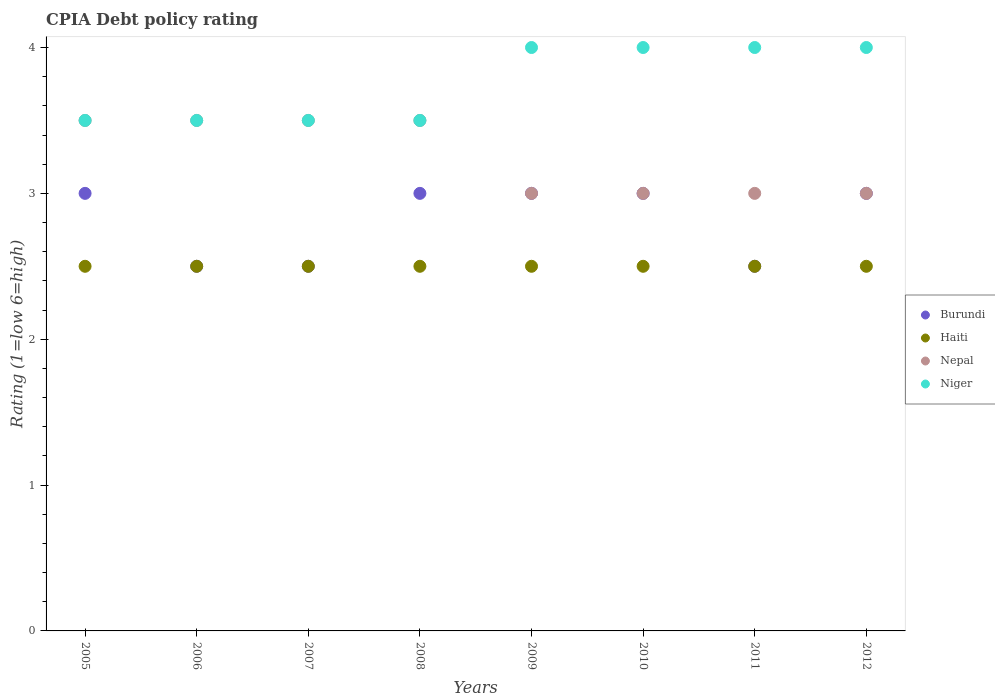Across all years, what is the maximum CPIA rating in Haiti?
Ensure brevity in your answer.  2.5. Across all years, what is the minimum CPIA rating in Niger?
Provide a succinct answer. 3.5. In which year was the CPIA rating in Haiti maximum?
Provide a succinct answer. 2005. What is the total CPIA rating in Niger in the graph?
Keep it short and to the point. 30. What is the difference between the CPIA rating in Haiti in 2008 and that in 2012?
Give a very brief answer. 0. What is the average CPIA rating in Niger per year?
Provide a short and direct response. 3.75. In the year 2012, what is the difference between the CPIA rating in Niger and CPIA rating in Nepal?
Offer a very short reply. 1. In how many years, is the CPIA rating in Nepal greater than 0.4?
Ensure brevity in your answer.  8. What is the difference between the highest and the lowest CPIA rating in Nepal?
Offer a very short reply. 0.5. In how many years, is the CPIA rating in Burundi greater than the average CPIA rating in Burundi taken over all years?
Make the answer very short. 5. Is the sum of the CPIA rating in Burundi in 2007 and 2011 greater than the maximum CPIA rating in Haiti across all years?
Offer a terse response. Yes. Is it the case that in every year, the sum of the CPIA rating in Haiti and CPIA rating in Nepal  is greater than the sum of CPIA rating in Niger and CPIA rating in Burundi?
Your answer should be compact. No. Is the CPIA rating in Niger strictly greater than the CPIA rating in Nepal over the years?
Your answer should be very brief. No. Is the CPIA rating in Haiti strictly less than the CPIA rating in Burundi over the years?
Your answer should be compact. No. How many dotlines are there?
Provide a short and direct response. 4. How many years are there in the graph?
Offer a very short reply. 8. Are the values on the major ticks of Y-axis written in scientific E-notation?
Provide a short and direct response. No. Does the graph contain grids?
Provide a short and direct response. No. Where does the legend appear in the graph?
Ensure brevity in your answer.  Center right. How many legend labels are there?
Offer a very short reply. 4. What is the title of the graph?
Ensure brevity in your answer.  CPIA Debt policy rating. What is the label or title of the Y-axis?
Offer a terse response. Rating (1=low 6=high). What is the Rating (1=low 6=high) of Burundi in 2005?
Offer a terse response. 3. What is the Rating (1=low 6=high) in Haiti in 2005?
Give a very brief answer. 2.5. What is the Rating (1=low 6=high) in Nepal in 2005?
Provide a short and direct response. 3.5. What is the Rating (1=low 6=high) in Niger in 2005?
Your answer should be compact. 3.5. What is the Rating (1=low 6=high) in Haiti in 2006?
Offer a terse response. 2.5. What is the Rating (1=low 6=high) of Niger in 2006?
Offer a terse response. 3.5. What is the Rating (1=low 6=high) of Burundi in 2007?
Your answer should be very brief. 2.5. What is the Rating (1=low 6=high) of Haiti in 2008?
Provide a short and direct response. 2.5. What is the Rating (1=low 6=high) in Nepal in 2008?
Give a very brief answer. 3.5. What is the Rating (1=low 6=high) in Burundi in 2009?
Make the answer very short. 3. What is the Rating (1=low 6=high) of Haiti in 2009?
Provide a short and direct response. 2.5. What is the Rating (1=low 6=high) of Haiti in 2010?
Provide a short and direct response. 2.5. What is the Rating (1=low 6=high) in Nepal in 2010?
Your answer should be compact. 3. What is the Rating (1=low 6=high) in Niger in 2010?
Your answer should be very brief. 4. What is the Rating (1=low 6=high) in Burundi in 2011?
Give a very brief answer. 2.5. What is the Rating (1=low 6=high) in Haiti in 2011?
Give a very brief answer. 2.5. What is the Rating (1=low 6=high) of Burundi in 2012?
Make the answer very short. 3. What is the Rating (1=low 6=high) in Haiti in 2012?
Offer a terse response. 2.5. What is the Rating (1=low 6=high) of Nepal in 2012?
Your answer should be compact. 3. Across all years, what is the maximum Rating (1=low 6=high) of Burundi?
Offer a terse response. 3. Across all years, what is the maximum Rating (1=low 6=high) in Nepal?
Ensure brevity in your answer.  3.5. Across all years, what is the minimum Rating (1=low 6=high) in Burundi?
Your answer should be very brief. 2.5. Across all years, what is the minimum Rating (1=low 6=high) of Nepal?
Make the answer very short. 3. What is the difference between the Rating (1=low 6=high) of Burundi in 2005 and that in 2006?
Ensure brevity in your answer.  0.5. What is the difference between the Rating (1=low 6=high) in Niger in 2005 and that in 2006?
Ensure brevity in your answer.  0. What is the difference between the Rating (1=low 6=high) of Nepal in 2005 and that in 2007?
Offer a terse response. 0. What is the difference between the Rating (1=low 6=high) in Niger in 2005 and that in 2007?
Keep it short and to the point. 0. What is the difference between the Rating (1=low 6=high) in Nepal in 2005 and that in 2008?
Keep it short and to the point. 0. What is the difference between the Rating (1=low 6=high) of Niger in 2005 and that in 2008?
Your answer should be very brief. 0. What is the difference between the Rating (1=low 6=high) of Nepal in 2005 and that in 2009?
Provide a succinct answer. 0.5. What is the difference between the Rating (1=low 6=high) in Burundi in 2005 and that in 2011?
Give a very brief answer. 0.5. What is the difference between the Rating (1=low 6=high) in Haiti in 2005 and that in 2011?
Keep it short and to the point. 0. What is the difference between the Rating (1=low 6=high) of Niger in 2005 and that in 2011?
Your answer should be very brief. -0.5. What is the difference between the Rating (1=low 6=high) of Burundi in 2005 and that in 2012?
Offer a very short reply. 0. What is the difference between the Rating (1=low 6=high) of Nepal in 2005 and that in 2012?
Offer a very short reply. 0.5. What is the difference between the Rating (1=low 6=high) in Burundi in 2006 and that in 2007?
Provide a succinct answer. 0. What is the difference between the Rating (1=low 6=high) of Burundi in 2006 and that in 2008?
Keep it short and to the point. -0.5. What is the difference between the Rating (1=low 6=high) in Haiti in 2006 and that in 2008?
Ensure brevity in your answer.  0. What is the difference between the Rating (1=low 6=high) of Nepal in 2006 and that in 2008?
Give a very brief answer. 0. What is the difference between the Rating (1=low 6=high) in Niger in 2006 and that in 2008?
Provide a succinct answer. 0. What is the difference between the Rating (1=low 6=high) of Niger in 2006 and that in 2009?
Make the answer very short. -0.5. What is the difference between the Rating (1=low 6=high) in Burundi in 2006 and that in 2010?
Offer a very short reply. -0.5. What is the difference between the Rating (1=low 6=high) of Niger in 2006 and that in 2010?
Provide a short and direct response. -0.5. What is the difference between the Rating (1=low 6=high) in Nepal in 2006 and that in 2011?
Your answer should be compact. 0.5. What is the difference between the Rating (1=low 6=high) of Burundi in 2006 and that in 2012?
Offer a very short reply. -0.5. What is the difference between the Rating (1=low 6=high) in Haiti in 2006 and that in 2012?
Your answer should be very brief. 0. What is the difference between the Rating (1=low 6=high) of Haiti in 2007 and that in 2008?
Your response must be concise. 0. What is the difference between the Rating (1=low 6=high) in Haiti in 2007 and that in 2009?
Your answer should be compact. 0. What is the difference between the Rating (1=low 6=high) in Burundi in 2007 and that in 2010?
Keep it short and to the point. -0.5. What is the difference between the Rating (1=low 6=high) in Haiti in 2007 and that in 2010?
Provide a short and direct response. 0. What is the difference between the Rating (1=low 6=high) in Haiti in 2007 and that in 2011?
Provide a succinct answer. 0. What is the difference between the Rating (1=low 6=high) of Burundi in 2007 and that in 2012?
Provide a short and direct response. -0.5. What is the difference between the Rating (1=low 6=high) in Haiti in 2007 and that in 2012?
Make the answer very short. 0. What is the difference between the Rating (1=low 6=high) in Burundi in 2008 and that in 2009?
Your response must be concise. 0. What is the difference between the Rating (1=low 6=high) in Haiti in 2008 and that in 2009?
Make the answer very short. 0. What is the difference between the Rating (1=low 6=high) in Niger in 2008 and that in 2009?
Your response must be concise. -0.5. What is the difference between the Rating (1=low 6=high) in Nepal in 2008 and that in 2010?
Your answer should be very brief. 0.5. What is the difference between the Rating (1=low 6=high) in Niger in 2008 and that in 2010?
Your response must be concise. -0.5. What is the difference between the Rating (1=low 6=high) of Burundi in 2008 and that in 2011?
Offer a very short reply. 0.5. What is the difference between the Rating (1=low 6=high) in Haiti in 2008 and that in 2011?
Your answer should be very brief. 0. What is the difference between the Rating (1=low 6=high) in Burundi in 2008 and that in 2012?
Provide a short and direct response. 0. What is the difference between the Rating (1=low 6=high) of Haiti in 2008 and that in 2012?
Offer a terse response. 0. What is the difference between the Rating (1=low 6=high) of Nepal in 2008 and that in 2012?
Offer a terse response. 0.5. What is the difference between the Rating (1=low 6=high) of Haiti in 2009 and that in 2010?
Make the answer very short. 0. What is the difference between the Rating (1=low 6=high) in Haiti in 2009 and that in 2011?
Provide a short and direct response. 0. What is the difference between the Rating (1=low 6=high) in Nepal in 2009 and that in 2011?
Your response must be concise. 0. What is the difference between the Rating (1=low 6=high) of Niger in 2009 and that in 2011?
Ensure brevity in your answer.  0. What is the difference between the Rating (1=low 6=high) in Burundi in 2009 and that in 2012?
Your response must be concise. 0. What is the difference between the Rating (1=low 6=high) of Haiti in 2009 and that in 2012?
Your answer should be compact. 0. What is the difference between the Rating (1=low 6=high) of Nepal in 2009 and that in 2012?
Keep it short and to the point. 0. What is the difference between the Rating (1=low 6=high) of Burundi in 2010 and that in 2011?
Give a very brief answer. 0.5. What is the difference between the Rating (1=low 6=high) of Haiti in 2010 and that in 2011?
Provide a succinct answer. 0. What is the difference between the Rating (1=low 6=high) of Nepal in 2010 and that in 2011?
Give a very brief answer. 0. What is the difference between the Rating (1=low 6=high) of Niger in 2010 and that in 2011?
Your response must be concise. 0. What is the difference between the Rating (1=low 6=high) of Haiti in 2011 and that in 2012?
Your response must be concise. 0. What is the difference between the Rating (1=low 6=high) of Niger in 2011 and that in 2012?
Offer a very short reply. 0. What is the difference between the Rating (1=low 6=high) in Burundi in 2005 and the Rating (1=low 6=high) in Haiti in 2006?
Keep it short and to the point. 0.5. What is the difference between the Rating (1=low 6=high) of Burundi in 2005 and the Rating (1=low 6=high) of Nepal in 2006?
Your answer should be compact. -0.5. What is the difference between the Rating (1=low 6=high) of Burundi in 2005 and the Rating (1=low 6=high) of Niger in 2006?
Make the answer very short. -0.5. What is the difference between the Rating (1=low 6=high) in Nepal in 2005 and the Rating (1=low 6=high) in Niger in 2006?
Offer a terse response. 0. What is the difference between the Rating (1=low 6=high) of Burundi in 2005 and the Rating (1=low 6=high) of Haiti in 2007?
Keep it short and to the point. 0.5. What is the difference between the Rating (1=low 6=high) in Burundi in 2005 and the Rating (1=low 6=high) in Nepal in 2007?
Make the answer very short. -0.5. What is the difference between the Rating (1=low 6=high) in Haiti in 2005 and the Rating (1=low 6=high) in Niger in 2007?
Offer a very short reply. -1. What is the difference between the Rating (1=low 6=high) in Burundi in 2005 and the Rating (1=low 6=high) in Haiti in 2008?
Provide a short and direct response. 0.5. What is the difference between the Rating (1=low 6=high) in Burundi in 2005 and the Rating (1=low 6=high) in Nepal in 2008?
Give a very brief answer. -0.5. What is the difference between the Rating (1=low 6=high) of Haiti in 2005 and the Rating (1=low 6=high) of Niger in 2008?
Keep it short and to the point. -1. What is the difference between the Rating (1=low 6=high) in Nepal in 2005 and the Rating (1=low 6=high) in Niger in 2008?
Make the answer very short. 0. What is the difference between the Rating (1=low 6=high) in Burundi in 2005 and the Rating (1=low 6=high) in Nepal in 2009?
Your response must be concise. 0. What is the difference between the Rating (1=low 6=high) of Burundi in 2005 and the Rating (1=low 6=high) of Niger in 2009?
Your response must be concise. -1. What is the difference between the Rating (1=low 6=high) in Nepal in 2005 and the Rating (1=low 6=high) in Niger in 2009?
Ensure brevity in your answer.  -0.5. What is the difference between the Rating (1=low 6=high) of Burundi in 2005 and the Rating (1=low 6=high) of Haiti in 2010?
Make the answer very short. 0.5. What is the difference between the Rating (1=low 6=high) of Burundi in 2005 and the Rating (1=low 6=high) of Nepal in 2010?
Provide a succinct answer. 0. What is the difference between the Rating (1=low 6=high) of Burundi in 2005 and the Rating (1=low 6=high) of Niger in 2010?
Keep it short and to the point. -1. What is the difference between the Rating (1=low 6=high) in Haiti in 2005 and the Rating (1=low 6=high) in Niger in 2010?
Make the answer very short. -1.5. What is the difference between the Rating (1=low 6=high) of Burundi in 2005 and the Rating (1=low 6=high) of Nepal in 2011?
Keep it short and to the point. 0. What is the difference between the Rating (1=low 6=high) in Haiti in 2005 and the Rating (1=low 6=high) in Niger in 2011?
Give a very brief answer. -1.5. What is the difference between the Rating (1=low 6=high) in Burundi in 2005 and the Rating (1=low 6=high) in Niger in 2012?
Ensure brevity in your answer.  -1. What is the difference between the Rating (1=low 6=high) of Haiti in 2005 and the Rating (1=low 6=high) of Nepal in 2012?
Provide a succinct answer. -0.5. What is the difference between the Rating (1=low 6=high) in Haiti in 2005 and the Rating (1=low 6=high) in Niger in 2012?
Offer a terse response. -1.5. What is the difference between the Rating (1=low 6=high) in Nepal in 2005 and the Rating (1=low 6=high) in Niger in 2012?
Offer a terse response. -0.5. What is the difference between the Rating (1=low 6=high) in Burundi in 2006 and the Rating (1=low 6=high) in Haiti in 2007?
Keep it short and to the point. 0. What is the difference between the Rating (1=low 6=high) in Burundi in 2006 and the Rating (1=low 6=high) in Nepal in 2007?
Ensure brevity in your answer.  -1. What is the difference between the Rating (1=low 6=high) in Haiti in 2006 and the Rating (1=low 6=high) in Niger in 2007?
Provide a succinct answer. -1. What is the difference between the Rating (1=low 6=high) in Burundi in 2006 and the Rating (1=low 6=high) in Nepal in 2008?
Ensure brevity in your answer.  -1. What is the difference between the Rating (1=low 6=high) in Burundi in 2006 and the Rating (1=low 6=high) in Niger in 2009?
Keep it short and to the point. -1.5. What is the difference between the Rating (1=low 6=high) of Haiti in 2006 and the Rating (1=low 6=high) of Nepal in 2009?
Provide a succinct answer. -0.5. What is the difference between the Rating (1=low 6=high) of Nepal in 2006 and the Rating (1=low 6=high) of Niger in 2009?
Keep it short and to the point. -0.5. What is the difference between the Rating (1=low 6=high) of Burundi in 2006 and the Rating (1=low 6=high) of Haiti in 2010?
Make the answer very short. 0. What is the difference between the Rating (1=low 6=high) of Burundi in 2006 and the Rating (1=low 6=high) of Nepal in 2010?
Offer a very short reply. -0.5. What is the difference between the Rating (1=low 6=high) of Burundi in 2006 and the Rating (1=low 6=high) of Niger in 2010?
Provide a short and direct response. -1.5. What is the difference between the Rating (1=low 6=high) in Haiti in 2006 and the Rating (1=low 6=high) in Nepal in 2010?
Make the answer very short. -0.5. What is the difference between the Rating (1=low 6=high) of Haiti in 2006 and the Rating (1=low 6=high) of Niger in 2010?
Offer a very short reply. -1.5. What is the difference between the Rating (1=low 6=high) in Burundi in 2006 and the Rating (1=low 6=high) in Haiti in 2011?
Offer a terse response. 0. What is the difference between the Rating (1=low 6=high) of Burundi in 2006 and the Rating (1=low 6=high) of Nepal in 2011?
Make the answer very short. -0.5. What is the difference between the Rating (1=low 6=high) of Burundi in 2006 and the Rating (1=low 6=high) of Niger in 2011?
Your answer should be very brief. -1.5. What is the difference between the Rating (1=low 6=high) in Haiti in 2006 and the Rating (1=low 6=high) in Nepal in 2011?
Offer a terse response. -0.5. What is the difference between the Rating (1=low 6=high) of Haiti in 2006 and the Rating (1=low 6=high) of Niger in 2011?
Offer a very short reply. -1.5. What is the difference between the Rating (1=low 6=high) of Nepal in 2006 and the Rating (1=low 6=high) of Niger in 2011?
Ensure brevity in your answer.  -0.5. What is the difference between the Rating (1=low 6=high) of Burundi in 2006 and the Rating (1=low 6=high) of Haiti in 2012?
Offer a terse response. 0. What is the difference between the Rating (1=low 6=high) of Burundi in 2006 and the Rating (1=low 6=high) of Nepal in 2012?
Keep it short and to the point. -0.5. What is the difference between the Rating (1=low 6=high) in Haiti in 2006 and the Rating (1=low 6=high) in Niger in 2012?
Provide a succinct answer. -1.5. What is the difference between the Rating (1=low 6=high) of Nepal in 2006 and the Rating (1=low 6=high) of Niger in 2012?
Your response must be concise. -0.5. What is the difference between the Rating (1=low 6=high) of Haiti in 2007 and the Rating (1=low 6=high) of Nepal in 2008?
Offer a terse response. -1. What is the difference between the Rating (1=low 6=high) in Nepal in 2007 and the Rating (1=low 6=high) in Niger in 2008?
Give a very brief answer. 0. What is the difference between the Rating (1=low 6=high) of Burundi in 2007 and the Rating (1=low 6=high) of Nepal in 2009?
Your answer should be very brief. -0.5. What is the difference between the Rating (1=low 6=high) in Haiti in 2007 and the Rating (1=low 6=high) in Nepal in 2009?
Ensure brevity in your answer.  -0.5. What is the difference between the Rating (1=low 6=high) in Haiti in 2007 and the Rating (1=low 6=high) in Niger in 2009?
Provide a succinct answer. -1.5. What is the difference between the Rating (1=low 6=high) of Haiti in 2007 and the Rating (1=low 6=high) of Niger in 2010?
Offer a very short reply. -1.5. What is the difference between the Rating (1=low 6=high) in Burundi in 2007 and the Rating (1=low 6=high) in Haiti in 2011?
Your answer should be compact. 0. What is the difference between the Rating (1=low 6=high) in Nepal in 2007 and the Rating (1=low 6=high) in Niger in 2011?
Your answer should be very brief. -0.5. What is the difference between the Rating (1=low 6=high) of Burundi in 2007 and the Rating (1=low 6=high) of Haiti in 2012?
Ensure brevity in your answer.  0. What is the difference between the Rating (1=low 6=high) of Haiti in 2007 and the Rating (1=low 6=high) of Nepal in 2012?
Offer a very short reply. -0.5. What is the difference between the Rating (1=low 6=high) of Nepal in 2007 and the Rating (1=low 6=high) of Niger in 2012?
Offer a very short reply. -0.5. What is the difference between the Rating (1=low 6=high) in Burundi in 2008 and the Rating (1=low 6=high) in Niger in 2009?
Ensure brevity in your answer.  -1. What is the difference between the Rating (1=low 6=high) in Burundi in 2008 and the Rating (1=low 6=high) in Nepal in 2010?
Keep it short and to the point. 0. What is the difference between the Rating (1=low 6=high) in Haiti in 2008 and the Rating (1=low 6=high) in Niger in 2010?
Provide a succinct answer. -1.5. What is the difference between the Rating (1=low 6=high) of Nepal in 2008 and the Rating (1=low 6=high) of Niger in 2010?
Your answer should be very brief. -0.5. What is the difference between the Rating (1=low 6=high) in Burundi in 2008 and the Rating (1=low 6=high) in Nepal in 2011?
Your answer should be very brief. 0. What is the difference between the Rating (1=low 6=high) in Haiti in 2008 and the Rating (1=low 6=high) in Niger in 2011?
Provide a succinct answer. -1.5. What is the difference between the Rating (1=low 6=high) in Burundi in 2008 and the Rating (1=low 6=high) in Haiti in 2012?
Your answer should be very brief. 0.5. What is the difference between the Rating (1=low 6=high) in Burundi in 2008 and the Rating (1=low 6=high) in Nepal in 2012?
Provide a short and direct response. 0. What is the difference between the Rating (1=low 6=high) of Burundi in 2008 and the Rating (1=low 6=high) of Niger in 2012?
Keep it short and to the point. -1. What is the difference between the Rating (1=low 6=high) in Haiti in 2008 and the Rating (1=low 6=high) in Nepal in 2012?
Your answer should be compact. -0.5. What is the difference between the Rating (1=low 6=high) in Haiti in 2008 and the Rating (1=low 6=high) in Niger in 2012?
Offer a very short reply. -1.5. What is the difference between the Rating (1=low 6=high) in Burundi in 2009 and the Rating (1=low 6=high) in Niger in 2010?
Offer a terse response. -1. What is the difference between the Rating (1=low 6=high) of Haiti in 2009 and the Rating (1=low 6=high) of Nepal in 2010?
Your response must be concise. -0.5. What is the difference between the Rating (1=low 6=high) in Nepal in 2009 and the Rating (1=low 6=high) in Niger in 2010?
Your response must be concise. -1. What is the difference between the Rating (1=low 6=high) of Burundi in 2009 and the Rating (1=low 6=high) of Haiti in 2011?
Make the answer very short. 0.5. What is the difference between the Rating (1=low 6=high) of Burundi in 2009 and the Rating (1=low 6=high) of Niger in 2011?
Offer a very short reply. -1. What is the difference between the Rating (1=low 6=high) of Haiti in 2009 and the Rating (1=low 6=high) of Nepal in 2011?
Offer a terse response. -0.5. What is the difference between the Rating (1=low 6=high) in Haiti in 2009 and the Rating (1=low 6=high) in Niger in 2011?
Make the answer very short. -1.5. What is the difference between the Rating (1=low 6=high) of Nepal in 2009 and the Rating (1=low 6=high) of Niger in 2011?
Ensure brevity in your answer.  -1. What is the difference between the Rating (1=low 6=high) of Haiti in 2009 and the Rating (1=low 6=high) of Niger in 2012?
Keep it short and to the point. -1.5. What is the difference between the Rating (1=low 6=high) of Burundi in 2010 and the Rating (1=low 6=high) of Haiti in 2011?
Offer a very short reply. 0.5. What is the difference between the Rating (1=low 6=high) of Haiti in 2010 and the Rating (1=low 6=high) of Niger in 2011?
Your answer should be very brief. -1.5. What is the difference between the Rating (1=low 6=high) in Nepal in 2010 and the Rating (1=low 6=high) in Niger in 2011?
Ensure brevity in your answer.  -1. What is the difference between the Rating (1=low 6=high) of Burundi in 2010 and the Rating (1=low 6=high) of Haiti in 2012?
Provide a short and direct response. 0.5. What is the difference between the Rating (1=low 6=high) in Burundi in 2010 and the Rating (1=low 6=high) in Nepal in 2012?
Keep it short and to the point. 0. What is the difference between the Rating (1=low 6=high) in Burundi in 2010 and the Rating (1=low 6=high) in Niger in 2012?
Your answer should be very brief. -1. What is the difference between the Rating (1=low 6=high) in Haiti in 2010 and the Rating (1=low 6=high) in Niger in 2012?
Give a very brief answer. -1.5. What is the difference between the Rating (1=low 6=high) of Burundi in 2011 and the Rating (1=low 6=high) of Haiti in 2012?
Ensure brevity in your answer.  0. What is the difference between the Rating (1=low 6=high) in Burundi in 2011 and the Rating (1=low 6=high) in Nepal in 2012?
Your answer should be very brief. -0.5. What is the difference between the Rating (1=low 6=high) in Haiti in 2011 and the Rating (1=low 6=high) in Nepal in 2012?
Provide a short and direct response. -0.5. What is the difference between the Rating (1=low 6=high) in Nepal in 2011 and the Rating (1=low 6=high) in Niger in 2012?
Your response must be concise. -1. What is the average Rating (1=low 6=high) of Burundi per year?
Your answer should be very brief. 2.81. What is the average Rating (1=low 6=high) in Haiti per year?
Provide a succinct answer. 2.5. What is the average Rating (1=low 6=high) in Nepal per year?
Provide a short and direct response. 3.25. What is the average Rating (1=low 6=high) of Niger per year?
Offer a terse response. 3.75. In the year 2005, what is the difference between the Rating (1=low 6=high) of Burundi and Rating (1=low 6=high) of Haiti?
Your answer should be compact. 0.5. In the year 2005, what is the difference between the Rating (1=low 6=high) of Burundi and Rating (1=low 6=high) of Nepal?
Offer a very short reply. -0.5. In the year 2005, what is the difference between the Rating (1=low 6=high) in Haiti and Rating (1=low 6=high) in Nepal?
Provide a short and direct response. -1. In the year 2005, what is the difference between the Rating (1=low 6=high) of Nepal and Rating (1=low 6=high) of Niger?
Provide a short and direct response. 0. In the year 2006, what is the difference between the Rating (1=low 6=high) of Burundi and Rating (1=low 6=high) of Nepal?
Your response must be concise. -1. In the year 2006, what is the difference between the Rating (1=low 6=high) in Burundi and Rating (1=low 6=high) in Niger?
Make the answer very short. -1. In the year 2006, what is the difference between the Rating (1=low 6=high) in Haiti and Rating (1=low 6=high) in Nepal?
Keep it short and to the point. -1. In the year 2007, what is the difference between the Rating (1=low 6=high) in Burundi and Rating (1=low 6=high) in Haiti?
Your answer should be very brief. 0. In the year 2007, what is the difference between the Rating (1=low 6=high) of Haiti and Rating (1=low 6=high) of Niger?
Provide a short and direct response. -1. In the year 2008, what is the difference between the Rating (1=low 6=high) in Burundi and Rating (1=low 6=high) in Haiti?
Keep it short and to the point. 0.5. In the year 2008, what is the difference between the Rating (1=low 6=high) of Burundi and Rating (1=low 6=high) of Nepal?
Your answer should be very brief. -0.5. In the year 2008, what is the difference between the Rating (1=low 6=high) in Burundi and Rating (1=low 6=high) in Niger?
Give a very brief answer. -0.5. In the year 2008, what is the difference between the Rating (1=low 6=high) in Nepal and Rating (1=low 6=high) in Niger?
Your response must be concise. 0. In the year 2009, what is the difference between the Rating (1=low 6=high) in Burundi and Rating (1=low 6=high) in Nepal?
Your response must be concise. 0. In the year 2010, what is the difference between the Rating (1=low 6=high) of Burundi and Rating (1=low 6=high) of Haiti?
Your response must be concise. 0.5. In the year 2010, what is the difference between the Rating (1=low 6=high) in Burundi and Rating (1=low 6=high) in Niger?
Offer a terse response. -1. In the year 2010, what is the difference between the Rating (1=low 6=high) of Haiti and Rating (1=low 6=high) of Niger?
Offer a terse response. -1.5. In the year 2010, what is the difference between the Rating (1=low 6=high) of Nepal and Rating (1=low 6=high) of Niger?
Offer a terse response. -1. In the year 2011, what is the difference between the Rating (1=low 6=high) of Burundi and Rating (1=low 6=high) of Haiti?
Provide a short and direct response. 0. In the year 2011, what is the difference between the Rating (1=low 6=high) of Burundi and Rating (1=low 6=high) of Nepal?
Make the answer very short. -0.5. In the year 2012, what is the difference between the Rating (1=low 6=high) of Haiti and Rating (1=low 6=high) of Niger?
Ensure brevity in your answer.  -1.5. What is the ratio of the Rating (1=low 6=high) in Burundi in 2005 to that in 2006?
Keep it short and to the point. 1.2. What is the ratio of the Rating (1=low 6=high) in Haiti in 2005 to that in 2006?
Ensure brevity in your answer.  1. What is the ratio of the Rating (1=low 6=high) in Niger in 2005 to that in 2006?
Your answer should be compact. 1. What is the ratio of the Rating (1=low 6=high) of Burundi in 2005 to that in 2007?
Give a very brief answer. 1.2. What is the ratio of the Rating (1=low 6=high) of Burundi in 2005 to that in 2008?
Your response must be concise. 1. What is the ratio of the Rating (1=low 6=high) of Haiti in 2005 to that in 2008?
Your response must be concise. 1. What is the ratio of the Rating (1=low 6=high) of Haiti in 2005 to that in 2010?
Ensure brevity in your answer.  1. What is the ratio of the Rating (1=low 6=high) in Nepal in 2005 to that in 2010?
Provide a short and direct response. 1.17. What is the ratio of the Rating (1=low 6=high) of Burundi in 2005 to that in 2011?
Provide a succinct answer. 1.2. What is the ratio of the Rating (1=low 6=high) in Niger in 2005 to that in 2011?
Your answer should be very brief. 0.88. What is the ratio of the Rating (1=low 6=high) of Burundi in 2005 to that in 2012?
Provide a succinct answer. 1. What is the ratio of the Rating (1=low 6=high) of Nepal in 2006 to that in 2009?
Give a very brief answer. 1.17. What is the ratio of the Rating (1=low 6=high) in Burundi in 2006 to that in 2010?
Keep it short and to the point. 0.83. What is the ratio of the Rating (1=low 6=high) of Nepal in 2006 to that in 2010?
Provide a succinct answer. 1.17. What is the ratio of the Rating (1=low 6=high) in Niger in 2006 to that in 2010?
Your response must be concise. 0.88. What is the ratio of the Rating (1=low 6=high) of Burundi in 2006 to that in 2011?
Make the answer very short. 1. What is the ratio of the Rating (1=low 6=high) of Nepal in 2006 to that in 2011?
Ensure brevity in your answer.  1.17. What is the ratio of the Rating (1=low 6=high) in Niger in 2006 to that in 2011?
Offer a terse response. 0.88. What is the ratio of the Rating (1=low 6=high) of Haiti in 2006 to that in 2012?
Keep it short and to the point. 1. What is the ratio of the Rating (1=low 6=high) in Niger in 2006 to that in 2012?
Your response must be concise. 0.88. What is the ratio of the Rating (1=low 6=high) of Burundi in 2007 to that in 2008?
Your response must be concise. 0.83. What is the ratio of the Rating (1=low 6=high) of Haiti in 2007 to that in 2008?
Provide a short and direct response. 1. What is the ratio of the Rating (1=low 6=high) in Nepal in 2007 to that in 2008?
Your answer should be compact. 1. What is the ratio of the Rating (1=low 6=high) of Niger in 2007 to that in 2008?
Offer a very short reply. 1. What is the ratio of the Rating (1=low 6=high) in Burundi in 2007 to that in 2009?
Your answer should be very brief. 0.83. What is the ratio of the Rating (1=low 6=high) in Haiti in 2007 to that in 2009?
Keep it short and to the point. 1. What is the ratio of the Rating (1=low 6=high) of Nepal in 2007 to that in 2010?
Offer a terse response. 1.17. What is the ratio of the Rating (1=low 6=high) in Niger in 2007 to that in 2010?
Offer a very short reply. 0.88. What is the ratio of the Rating (1=low 6=high) of Haiti in 2007 to that in 2011?
Your answer should be compact. 1. What is the ratio of the Rating (1=low 6=high) of Niger in 2007 to that in 2011?
Offer a terse response. 0.88. What is the ratio of the Rating (1=low 6=high) of Burundi in 2007 to that in 2012?
Offer a very short reply. 0.83. What is the ratio of the Rating (1=low 6=high) in Haiti in 2007 to that in 2012?
Offer a terse response. 1. What is the ratio of the Rating (1=low 6=high) of Nepal in 2007 to that in 2012?
Provide a short and direct response. 1.17. What is the ratio of the Rating (1=low 6=high) in Burundi in 2008 to that in 2009?
Offer a very short reply. 1. What is the ratio of the Rating (1=low 6=high) in Nepal in 2008 to that in 2009?
Your answer should be very brief. 1.17. What is the ratio of the Rating (1=low 6=high) of Burundi in 2008 to that in 2010?
Provide a short and direct response. 1. What is the ratio of the Rating (1=low 6=high) in Nepal in 2008 to that in 2011?
Your answer should be compact. 1.17. What is the ratio of the Rating (1=low 6=high) of Burundi in 2008 to that in 2012?
Your answer should be compact. 1. What is the ratio of the Rating (1=low 6=high) in Haiti in 2008 to that in 2012?
Provide a short and direct response. 1. What is the ratio of the Rating (1=low 6=high) of Burundi in 2009 to that in 2010?
Your answer should be compact. 1. What is the ratio of the Rating (1=low 6=high) of Nepal in 2009 to that in 2010?
Ensure brevity in your answer.  1. What is the ratio of the Rating (1=low 6=high) in Niger in 2009 to that in 2010?
Provide a succinct answer. 1. What is the ratio of the Rating (1=low 6=high) in Burundi in 2009 to that in 2011?
Make the answer very short. 1.2. What is the ratio of the Rating (1=low 6=high) in Nepal in 2009 to that in 2011?
Offer a terse response. 1. What is the ratio of the Rating (1=low 6=high) in Niger in 2009 to that in 2011?
Your answer should be very brief. 1. What is the ratio of the Rating (1=low 6=high) of Haiti in 2009 to that in 2012?
Your answer should be very brief. 1. What is the ratio of the Rating (1=low 6=high) in Nepal in 2009 to that in 2012?
Give a very brief answer. 1. What is the ratio of the Rating (1=low 6=high) in Niger in 2009 to that in 2012?
Offer a terse response. 1. What is the ratio of the Rating (1=low 6=high) in Burundi in 2010 to that in 2011?
Make the answer very short. 1.2. What is the ratio of the Rating (1=low 6=high) of Nepal in 2010 to that in 2011?
Ensure brevity in your answer.  1. What is the ratio of the Rating (1=low 6=high) of Niger in 2010 to that in 2011?
Keep it short and to the point. 1. What is the ratio of the Rating (1=low 6=high) in Haiti in 2010 to that in 2012?
Your response must be concise. 1. What is the ratio of the Rating (1=low 6=high) of Nepal in 2011 to that in 2012?
Offer a terse response. 1. What is the ratio of the Rating (1=low 6=high) of Niger in 2011 to that in 2012?
Make the answer very short. 1. What is the difference between the highest and the second highest Rating (1=low 6=high) of Nepal?
Provide a succinct answer. 0. What is the difference between the highest and the lowest Rating (1=low 6=high) in Burundi?
Provide a short and direct response. 0.5. What is the difference between the highest and the lowest Rating (1=low 6=high) of Nepal?
Offer a very short reply. 0.5. 